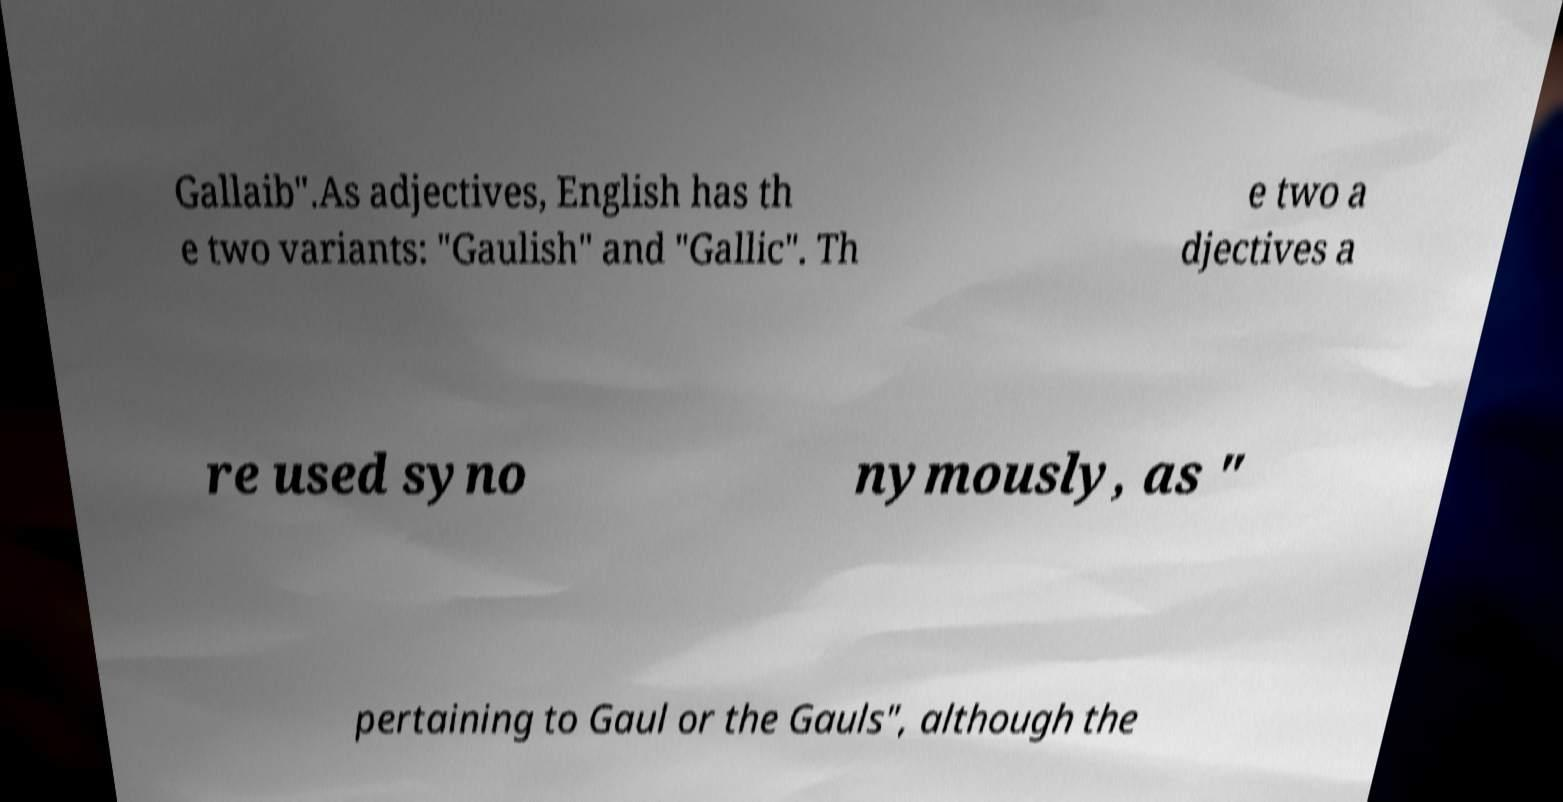Could you extract and type out the text from this image? Gallaib".As adjectives, English has th e two variants: "Gaulish" and "Gallic". Th e two a djectives a re used syno nymously, as " pertaining to Gaul or the Gauls", although the 